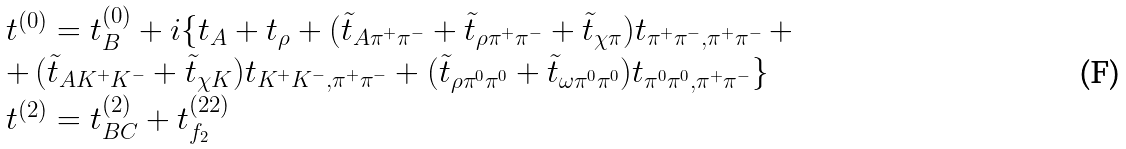<formula> <loc_0><loc_0><loc_500><loc_500>\begin{array} { l } { { t ^ { ( 0 ) } = t _ { B } ^ { ( 0 ) } + i \{ t _ { A } + t _ { \rho } + ( \tilde { t } _ { A \pi ^ { + } \pi ^ { - } } + \tilde { t } _ { \rho \pi ^ { + } \pi ^ { - } } + \tilde { t } _ { \chi \pi } ) t _ { \pi ^ { + } \pi ^ { - } , \pi ^ { + } \pi ^ { - } } \, + } } \\ { { + \, ( \tilde { t } _ { A K ^ { + } K ^ { - } } + \tilde { t } _ { \chi K } ) t _ { K ^ { + } K ^ { - } , \pi ^ { + } \pi ^ { - } } + ( \tilde { t } _ { \rho \pi ^ { 0 } \pi ^ { 0 } } + \tilde { t } _ { \omega \pi ^ { 0 } \pi ^ { 0 } } ) t _ { \pi ^ { 0 } \pi ^ { 0 } , \pi ^ { + } \pi ^ { - } } \} } } \\ { { t ^ { ( 2 ) } = t _ { B C } ^ { ( 2 ) } + t _ { f _ { 2 } } ^ { ( 2 2 ) } } } \end{array}</formula> 